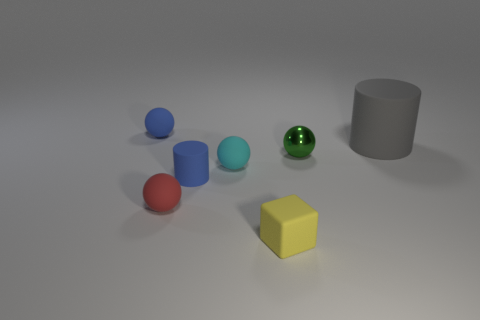Subtract all red rubber spheres. How many spheres are left? 3 Subtract all blue spheres. How many spheres are left? 3 Add 3 green metallic objects. How many objects exist? 10 Subtract all blocks. How many objects are left? 6 Subtract all gray balls. Subtract all green blocks. How many balls are left? 4 Add 4 small blue rubber things. How many small blue rubber things are left? 6 Add 1 big green rubber cylinders. How many big green rubber cylinders exist? 1 Subtract 1 red spheres. How many objects are left? 6 Subtract all green spheres. Subtract all cylinders. How many objects are left? 4 